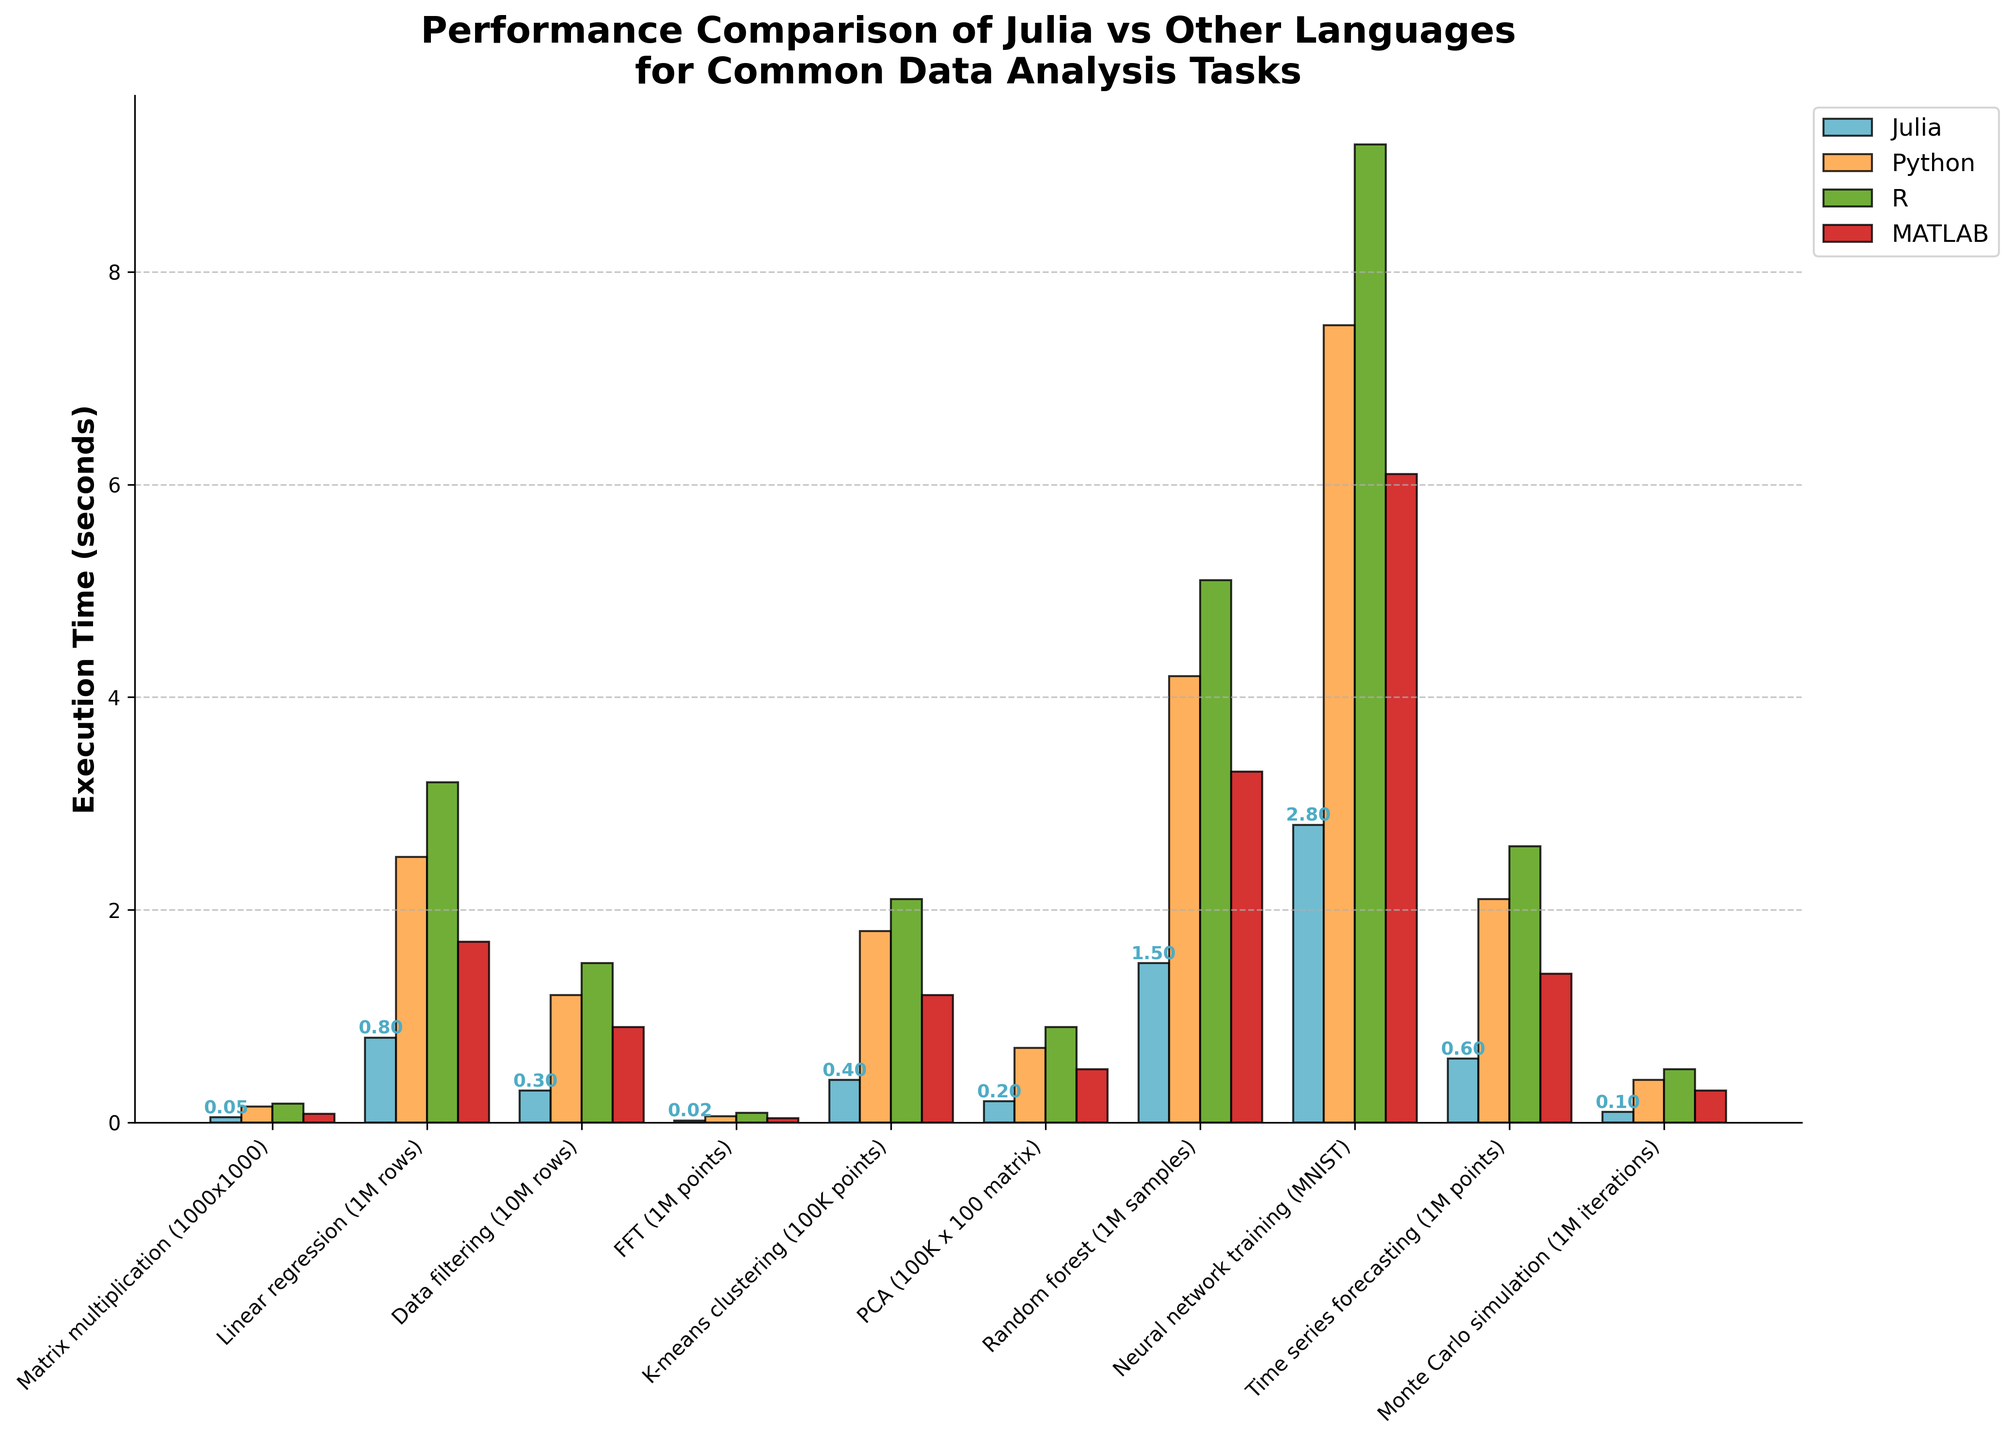Which language performs the best for Matrix multiplication (1000x1000)? Julia outperforms other languages in matrix multiplication with an execution time of 0.05 seconds. This is the lowest time observed compared to Python, R, and MATLAB.
Answer: Julia Which task has the closest execution times between Julia and MATLAB? For FFT (1M points), Julia and MATLAB have very close execution times of 0.02 seconds and 0.04 seconds respectively. The gap between them is smaller compared to other tasks.
Answer: FFT (1M points) What is the maximum execution time among all languages for Data filtering (10M rows)? The task Data filtering (10M rows) has the longest execution time of 1.5 seconds in R. By comparing the heights of the bars, R's bar is the tallest for this task.
Answer: 1.5 seconds What is the total execution time of Julia for all tasks combined? Sum up Julia's times for all tasks: 0.05 + 0.8 + 0.3 + 0.02 + 0.4 + 0.2 + 1.5 + 2.8 + 0.6 + 0.1 = 6.77 seconds.
Answer: 6.77 seconds Which task shows the greatest performance difference between Julia and Python? Neural network training (MNIST) shows the greatest performance difference. Julia takes 2.8 seconds while Python takes 7.5 seconds. The difference is 7.5 - 2.8 = 4.7 seconds.
Answer: Neural network training (4.7 seconds) For which tasks does Julia show more than 4 times better performance compared to Python? Julia has more than 4 times better performance for Matrix multiplication (0.05 vs 0.15 -> 0.05*4 = 0.20 > 0.15), Data filtering (0.3 vs 1.2 -> 0.3*4 = 1.2), FFT (0.02 vs 0.06 -> 0.02*4 = 0.08 > 0.06), Monte Carlo simulation (0.1 vs 0.4 -> 0.1*4 = 0.4), and PCA (0.2 vs 0.7 -> 0.2*4 = 0.8 > 0.7).
Answer: Matrix multiplication, Data filtering, FFT, Monte Carlo simulation, PCA What is the average execution time for MATLAB across all tasks? Sum up MATLAB's times and divide by 10: (0.08 + 1.7 + 0.9 + 0.04 + 1.2 + 0.5 + 3.3 + 6.1 + 1.4 + 0.3) / 10 = 15.52 / 10 = 1.552 seconds.
Answer: 1.552 seconds How does the performance of Julia compare to R for Linear regression (1M rows)? Julia takes 0.8 seconds while R takes 3.2 seconds. Julia's performance is 3.2 / 0.8 = 4 times better.
Answer: 4 times better What is the range of execution times for Julia? The range is calculated by subtracting the minimum value from the maximum value. For Julia, the minimum is 0.02 (FFT) and the maximum is 2.8 (Neural Network Training), so the range is 2.8 - 0.02 = 2.78 seconds.
Answer: 2.78 seconds 